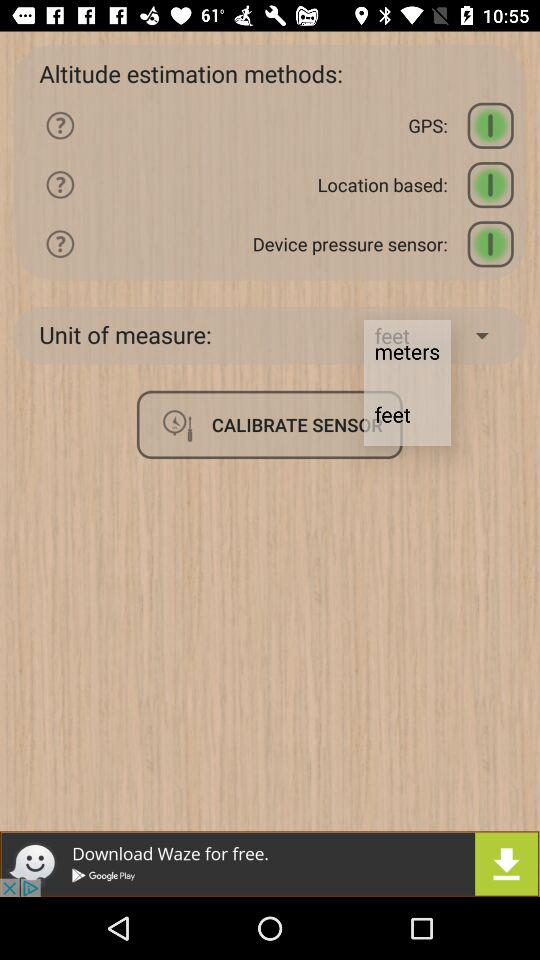What are the different units of measurement? The different units of measurement are meters and feet. 